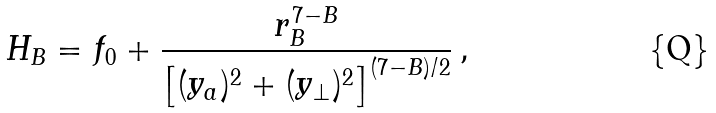<formula> <loc_0><loc_0><loc_500><loc_500>H _ { B } = f _ { 0 } + { \frac { r _ { B } ^ { 7 - B } } { \left [ ( { { y } _ { a } } ) ^ { 2 } + ( { { y } _ { \perp } } ) ^ { 2 } \right ] ^ { ( 7 - B ) / 2 } } } \, ,</formula> 